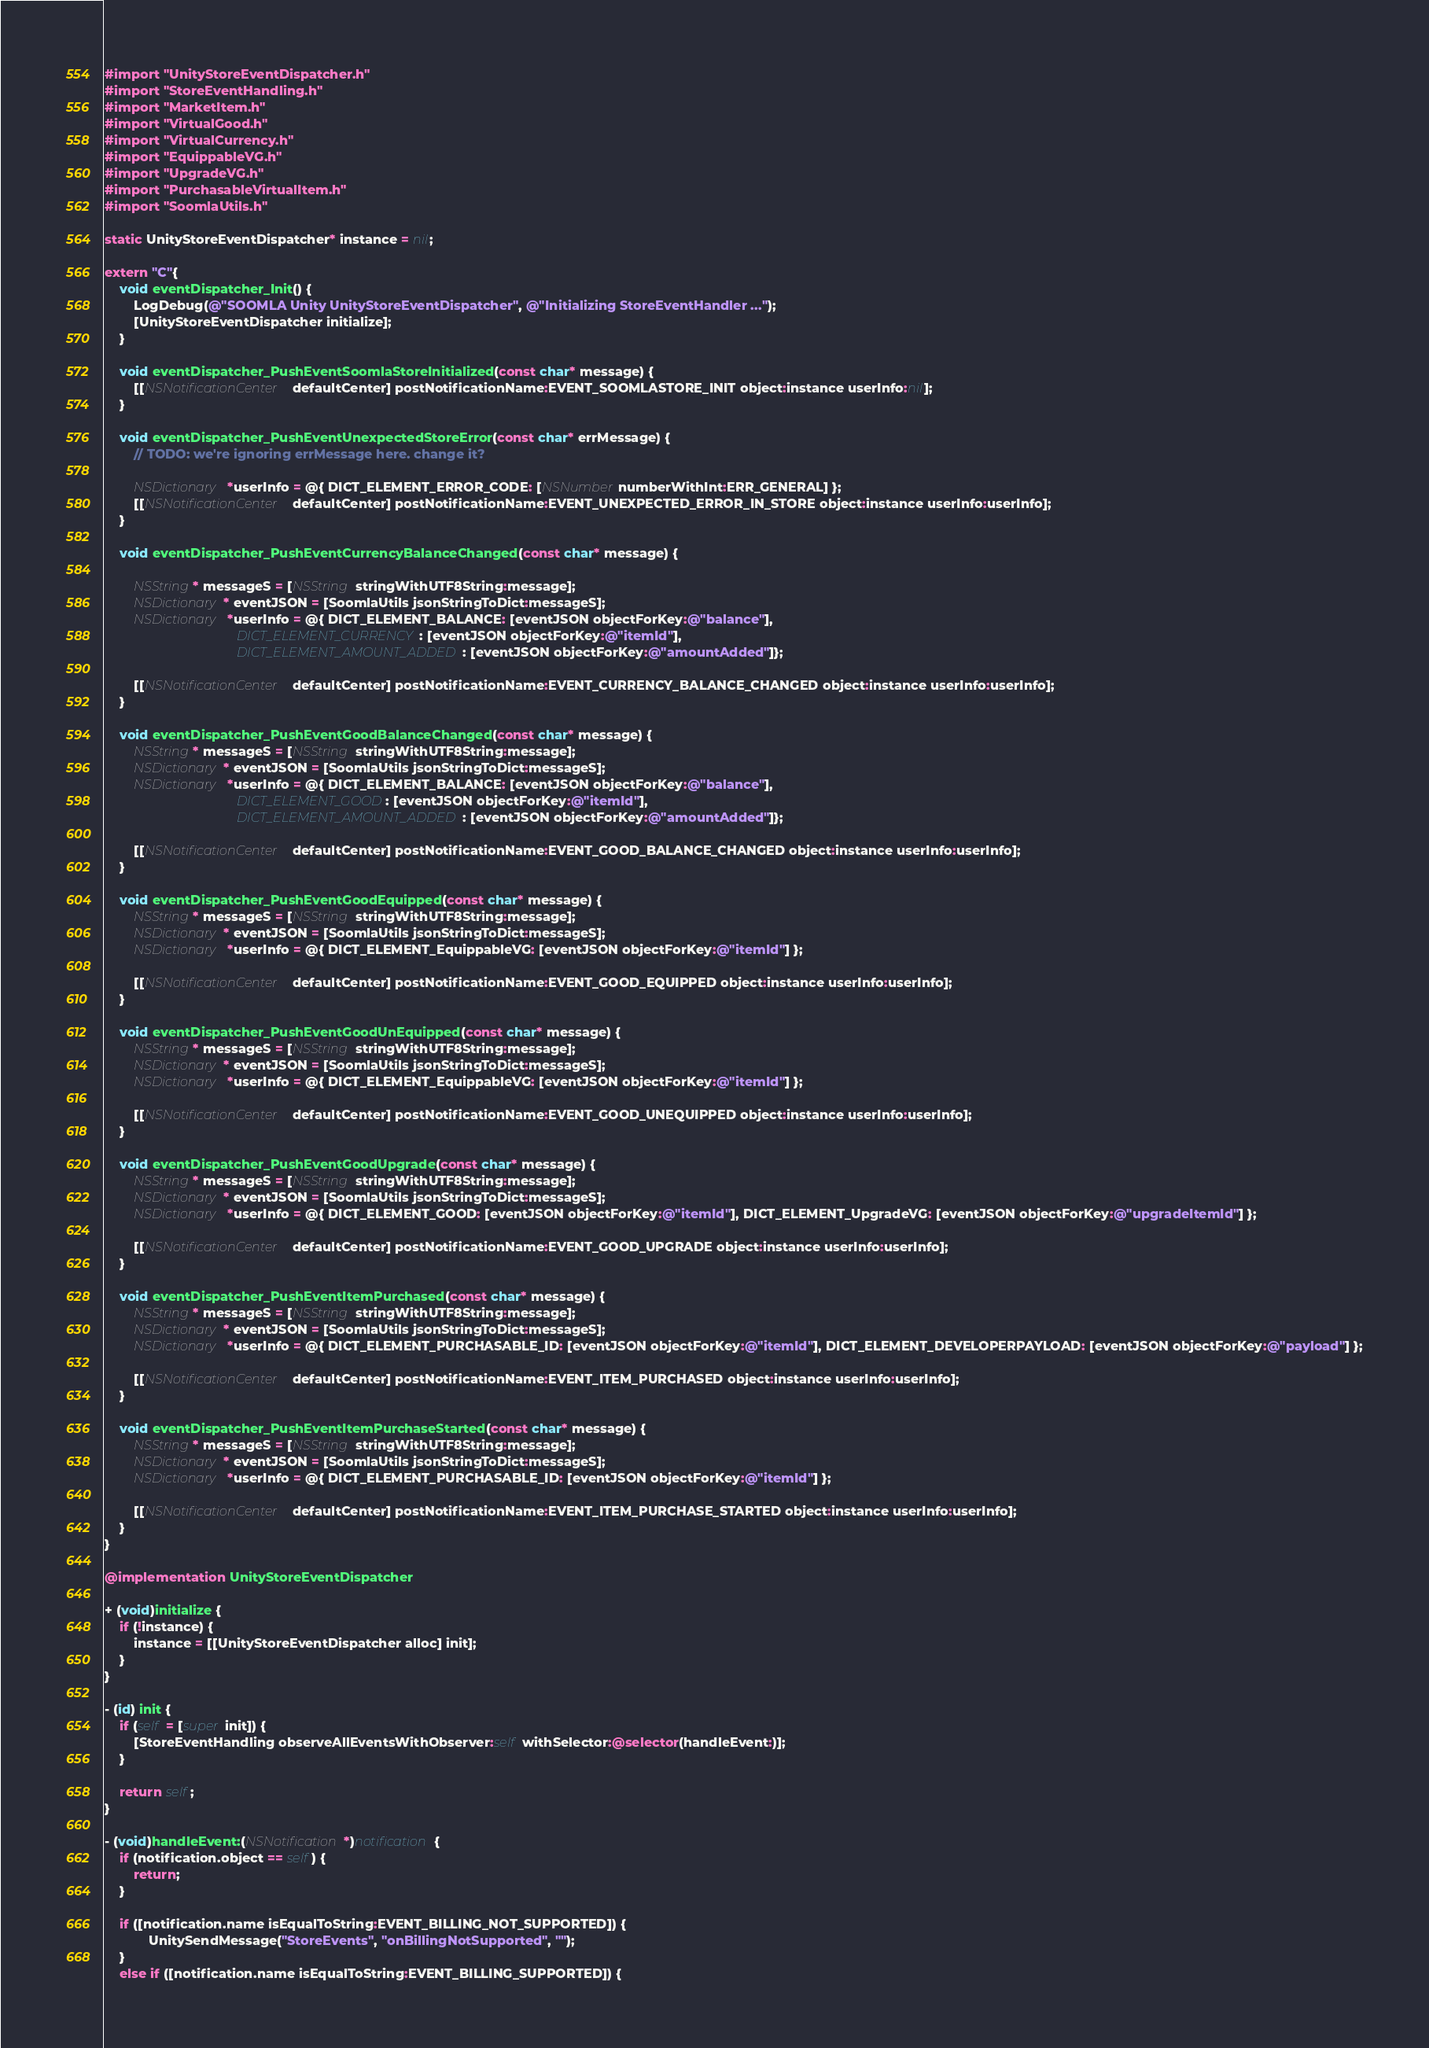Convert code to text. <code><loc_0><loc_0><loc_500><loc_500><_ObjectiveC_>
#import "UnityStoreEventDispatcher.h"
#import "StoreEventHandling.h"
#import "MarketItem.h"
#import "VirtualGood.h"
#import "VirtualCurrency.h"
#import "EquippableVG.h"
#import "UpgradeVG.h"
#import "PurchasableVirtualItem.h"
#import "SoomlaUtils.h"

static UnityStoreEventDispatcher* instance = nil;

extern "C"{
    void eventDispatcher_Init() {
        LogDebug(@"SOOMLA Unity UnityStoreEventDispatcher", @"Initializing StoreEventHandler ...");
        [UnityStoreEventDispatcher initialize];
    }
    
    void eventDispatcher_PushEventSoomlaStoreInitialized(const char* message) {
        [[NSNotificationCenter defaultCenter] postNotificationName:EVENT_SOOMLASTORE_INIT object:instance userInfo:nil];
    }
    
    void eventDispatcher_PushEventUnexpectedStoreError(const char* errMessage) {
        // TODO: we're ignoring errMessage here. change it?

        NSDictionary *userInfo = @{ DICT_ELEMENT_ERROR_CODE: [NSNumber numberWithInt:ERR_GENERAL] };
        [[NSNotificationCenter defaultCenter] postNotificationName:EVENT_UNEXPECTED_ERROR_IN_STORE object:instance userInfo:userInfo];
    }
    
    void eventDispatcher_PushEventCurrencyBalanceChanged(const char* message) {
        
        NSString* messageS = [NSString stringWithUTF8String:message];
        NSDictionary* eventJSON = [SoomlaUtils jsonStringToDict:messageS];
        NSDictionary *userInfo = @{ DICT_ELEMENT_BALANCE: [eventJSON objectForKey:@"balance"],
                                    DICT_ELEMENT_CURRENCY: [eventJSON objectForKey:@"itemId"],
                                    DICT_ELEMENT_AMOUNT_ADDED: [eventJSON objectForKey:@"amountAdded"]};
        
        [[NSNotificationCenter defaultCenter] postNotificationName:EVENT_CURRENCY_BALANCE_CHANGED object:instance userInfo:userInfo];
    }
    
    void eventDispatcher_PushEventGoodBalanceChanged(const char* message) {
        NSString* messageS = [NSString stringWithUTF8String:message];
        NSDictionary* eventJSON = [SoomlaUtils jsonStringToDict:messageS];
        NSDictionary *userInfo = @{ DICT_ELEMENT_BALANCE: [eventJSON objectForKey:@"balance"],
                                    DICT_ELEMENT_GOOD: [eventJSON objectForKey:@"itemId"],
                                    DICT_ELEMENT_AMOUNT_ADDED: [eventJSON objectForKey:@"amountAdded"]};
        
        [[NSNotificationCenter defaultCenter] postNotificationName:EVENT_GOOD_BALANCE_CHANGED object:instance userInfo:userInfo];
    }
    
    void eventDispatcher_PushEventGoodEquipped(const char* message) {
        NSString* messageS = [NSString stringWithUTF8String:message];
        NSDictionary* eventJSON = [SoomlaUtils jsonStringToDict:messageS];
        NSDictionary *userInfo = @{ DICT_ELEMENT_EquippableVG: [eventJSON objectForKey:@"itemId"] };
        
        [[NSNotificationCenter defaultCenter] postNotificationName:EVENT_GOOD_EQUIPPED object:instance userInfo:userInfo];
    }
    
    void eventDispatcher_PushEventGoodUnEquipped(const char* message) {
        NSString* messageS = [NSString stringWithUTF8String:message];
        NSDictionary* eventJSON = [SoomlaUtils jsonStringToDict:messageS];
        NSDictionary *userInfo = @{ DICT_ELEMENT_EquippableVG: [eventJSON objectForKey:@"itemId"] };
        
        [[NSNotificationCenter defaultCenter] postNotificationName:EVENT_GOOD_UNEQUIPPED object:instance userInfo:userInfo];
    }
    
    void eventDispatcher_PushEventGoodUpgrade(const char* message) {
        NSString* messageS = [NSString stringWithUTF8String:message];
        NSDictionary* eventJSON = [SoomlaUtils jsonStringToDict:messageS];
        NSDictionary *userInfo = @{ DICT_ELEMENT_GOOD: [eventJSON objectForKey:@"itemId"], DICT_ELEMENT_UpgradeVG: [eventJSON objectForKey:@"upgradeItemId"] };
        
        [[NSNotificationCenter defaultCenter] postNotificationName:EVENT_GOOD_UPGRADE object:instance userInfo:userInfo];
    }
    
    void eventDispatcher_PushEventItemPurchased(const char* message) {
        NSString* messageS = [NSString stringWithUTF8String:message];
        NSDictionary* eventJSON = [SoomlaUtils jsonStringToDict:messageS];
        NSDictionary *userInfo = @{ DICT_ELEMENT_PURCHASABLE_ID: [eventJSON objectForKey:@"itemId"], DICT_ELEMENT_DEVELOPERPAYLOAD: [eventJSON objectForKey:@"payload"] };

        [[NSNotificationCenter defaultCenter] postNotificationName:EVENT_ITEM_PURCHASED object:instance userInfo:userInfo];
    }
    
    void eventDispatcher_PushEventItemPurchaseStarted(const char* message) {
        NSString* messageS = [NSString stringWithUTF8String:message];
        NSDictionary* eventJSON = [SoomlaUtils jsonStringToDict:messageS];
        NSDictionary *userInfo = @{ DICT_ELEMENT_PURCHASABLE_ID: [eventJSON objectForKey:@"itemId"] };
        
        [[NSNotificationCenter defaultCenter] postNotificationName:EVENT_ITEM_PURCHASE_STARTED object:instance userInfo:userInfo];
    }
}

@implementation UnityStoreEventDispatcher

+ (void)initialize {
    if (!instance) {
        instance = [[UnityStoreEventDispatcher alloc] init];
    }
}

- (id) init {
    if (self = [super init]) {
        [StoreEventHandling observeAllEventsWithObserver:self withSelector:@selector(handleEvent:)];
    }

    return self;
}

- (void)handleEvent:(NSNotification*)notification{
    if (notification.object == self) {
        return;
    }
    
	if ([notification.name isEqualToString:EVENT_BILLING_NOT_SUPPORTED]) {
	        UnitySendMessage("StoreEvents", "onBillingNotSupported", "");
	}
	else if ([notification.name isEqualToString:EVENT_BILLING_SUPPORTED]) {</code> 